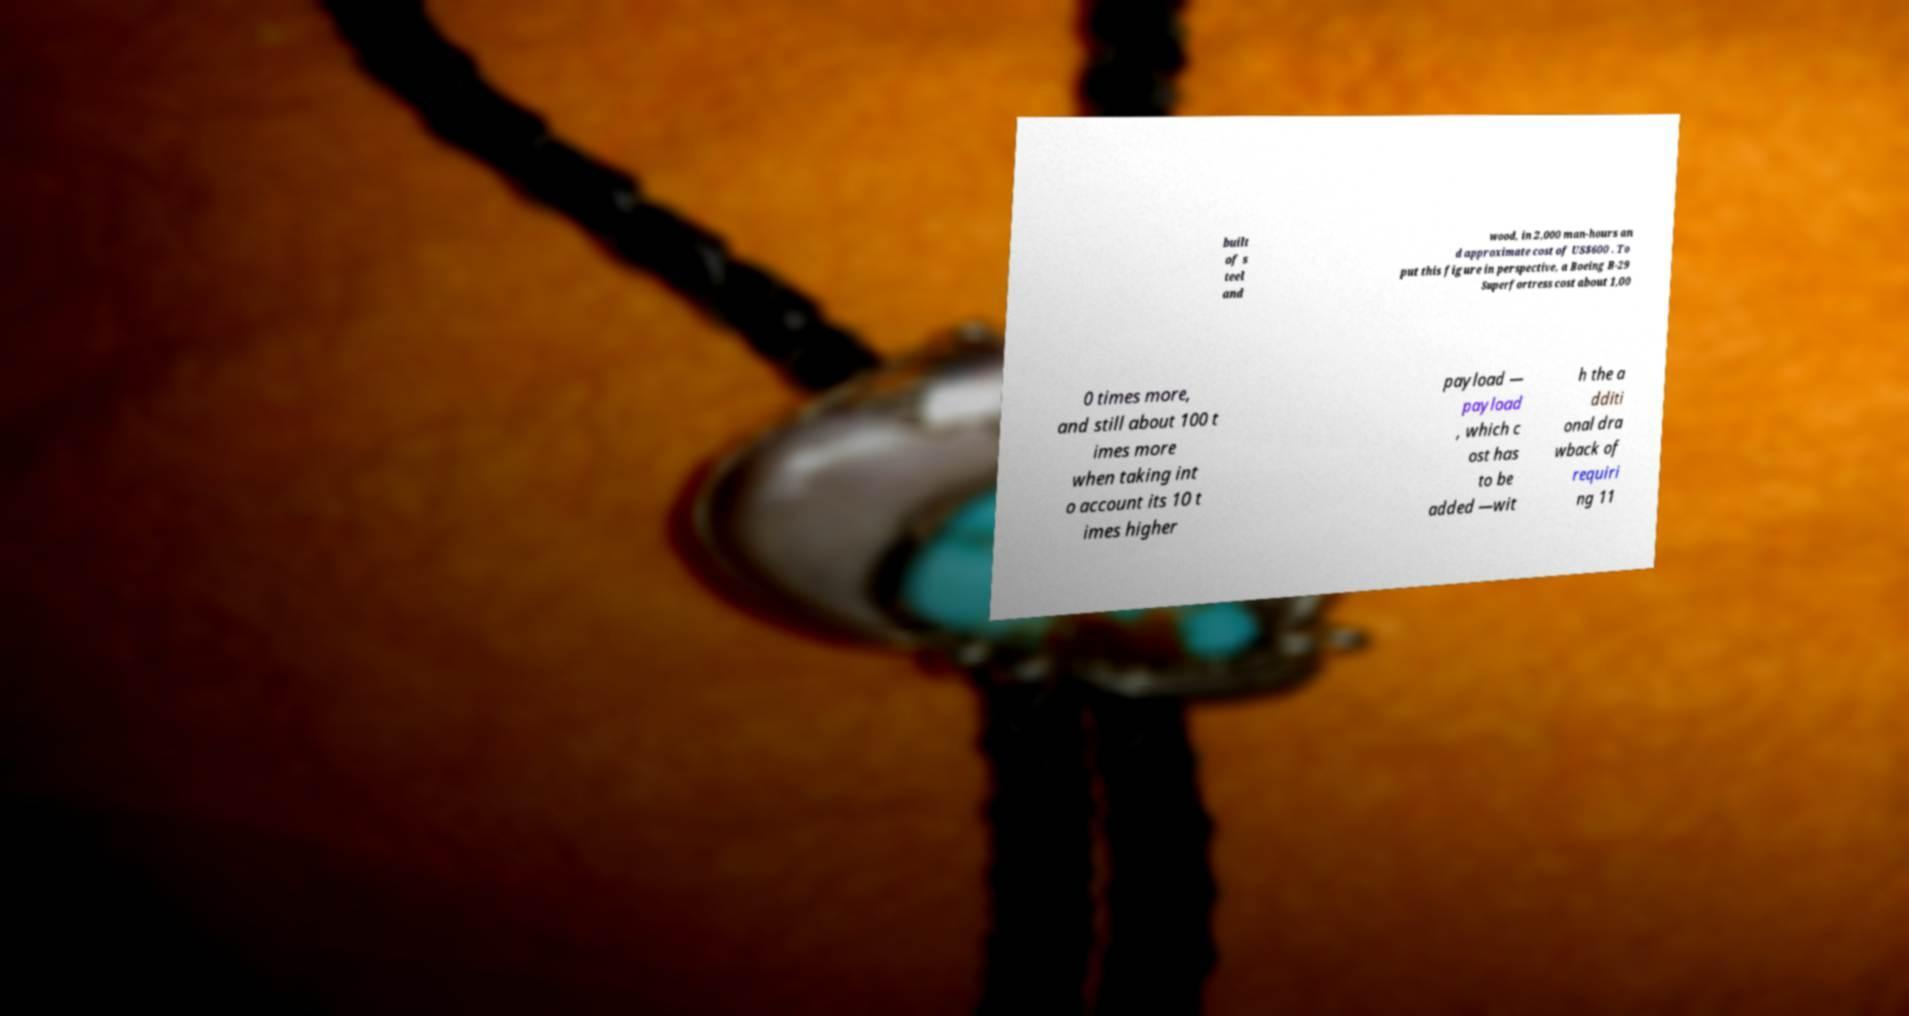Can you read and provide the text displayed in the image?This photo seems to have some interesting text. Can you extract and type it out for me? built of s teel and wood, in 2,000 man-hours an d approximate cost of US$600 . To put this figure in perspective, a Boeing B-29 Superfortress cost about 1,00 0 times more, and still about 100 t imes more when taking int o account its 10 t imes higher payload — payload , which c ost has to be added —wit h the a dditi onal dra wback of requiri ng 11 